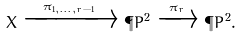<formula> <loc_0><loc_0><loc_500><loc_500>X \xrightarrow { \pi _ { 1 , \dots , r - 1 } } \tilde { \P } P ^ { 2 } \xrightarrow { \pi _ { r } } \P P ^ { 2 } .</formula> 